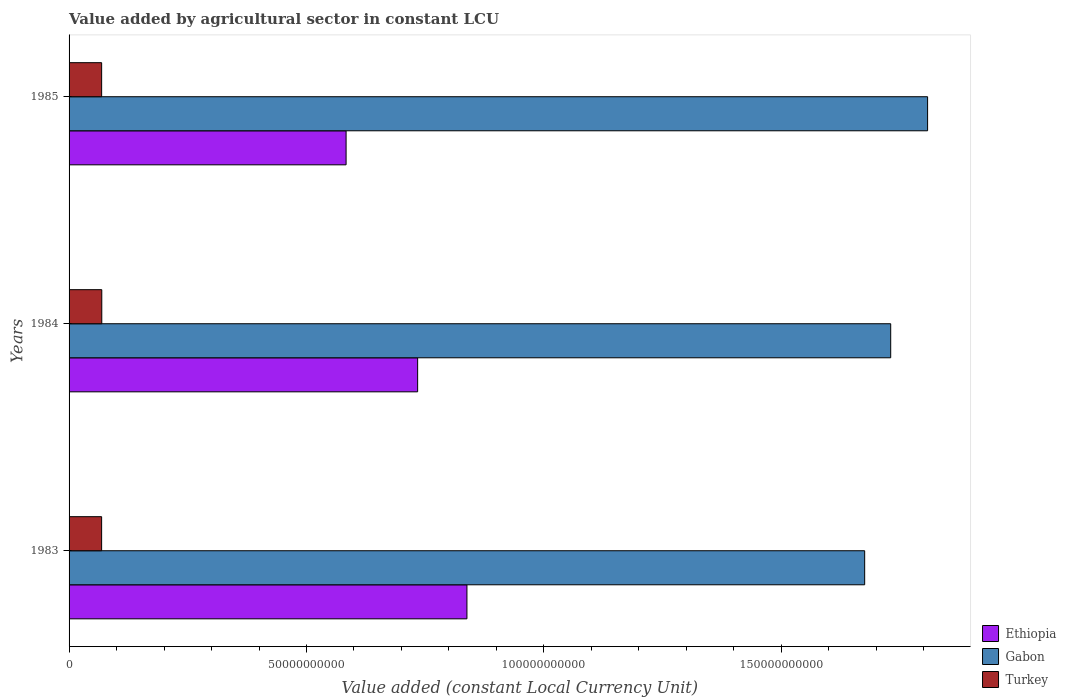How many different coloured bars are there?
Your answer should be very brief. 3. Are the number of bars per tick equal to the number of legend labels?
Keep it short and to the point. Yes. How many bars are there on the 1st tick from the bottom?
Your answer should be very brief. 3. What is the label of the 1st group of bars from the top?
Provide a short and direct response. 1985. What is the value added by agricultural sector in Ethiopia in 1983?
Offer a terse response. 8.38e+1. Across all years, what is the maximum value added by agricultural sector in Gabon?
Provide a succinct answer. 1.81e+11. Across all years, what is the minimum value added by agricultural sector in Turkey?
Provide a short and direct response. 6.86e+09. In which year was the value added by agricultural sector in Turkey maximum?
Your answer should be compact. 1984. In which year was the value added by agricultural sector in Ethiopia minimum?
Give a very brief answer. 1985. What is the total value added by agricultural sector in Turkey in the graph?
Make the answer very short. 2.06e+1. What is the difference between the value added by agricultural sector in Ethiopia in 1983 and that in 1985?
Your answer should be very brief. 2.55e+1. What is the difference between the value added by agricultural sector in Turkey in 1983 and the value added by agricultural sector in Ethiopia in 1984?
Your answer should be very brief. -6.66e+1. What is the average value added by agricultural sector in Ethiopia per year?
Ensure brevity in your answer.  7.18e+1. In the year 1983, what is the difference between the value added by agricultural sector in Turkey and value added by agricultural sector in Gabon?
Provide a short and direct response. -1.61e+11. In how many years, is the value added by agricultural sector in Ethiopia greater than 20000000000 LCU?
Provide a short and direct response. 3. What is the ratio of the value added by agricultural sector in Turkey in 1984 to that in 1985?
Provide a short and direct response. 1. What is the difference between the highest and the second highest value added by agricultural sector in Ethiopia?
Make the answer very short. 1.04e+1. What is the difference between the highest and the lowest value added by agricultural sector in Ethiopia?
Keep it short and to the point. 2.55e+1. What does the 1st bar from the bottom in 1983 represents?
Provide a succinct answer. Ethiopia. Is it the case that in every year, the sum of the value added by agricultural sector in Turkey and value added by agricultural sector in Gabon is greater than the value added by agricultural sector in Ethiopia?
Offer a very short reply. Yes. What is the difference between two consecutive major ticks on the X-axis?
Keep it short and to the point. 5.00e+1. Are the values on the major ticks of X-axis written in scientific E-notation?
Your response must be concise. No. Does the graph contain any zero values?
Provide a succinct answer. No. Does the graph contain grids?
Give a very brief answer. No. How are the legend labels stacked?
Provide a succinct answer. Vertical. What is the title of the graph?
Your answer should be very brief. Value added by agricultural sector in constant LCU. Does "Paraguay" appear as one of the legend labels in the graph?
Offer a very short reply. No. What is the label or title of the X-axis?
Your response must be concise. Value added (constant Local Currency Unit). What is the label or title of the Y-axis?
Provide a succinct answer. Years. What is the Value added (constant Local Currency Unit) in Ethiopia in 1983?
Give a very brief answer. 8.38e+1. What is the Value added (constant Local Currency Unit) of Gabon in 1983?
Your answer should be very brief. 1.68e+11. What is the Value added (constant Local Currency Unit) in Turkey in 1983?
Ensure brevity in your answer.  6.86e+09. What is the Value added (constant Local Currency Unit) of Ethiopia in 1984?
Offer a very short reply. 7.34e+1. What is the Value added (constant Local Currency Unit) in Gabon in 1984?
Your response must be concise. 1.73e+11. What is the Value added (constant Local Currency Unit) of Turkey in 1984?
Ensure brevity in your answer.  6.89e+09. What is the Value added (constant Local Currency Unit) in Ethiopia in 1985?
Your answer should be very brief. 5.83e+1. What is the Value added (constant Local Currency Unit) in Gabon in 1985?
Ensure brevity in your answer.  1.81e+11. What is the Value added (constant Local Currency Unit) of Turkey in 1985?
Keep it short and to the point. 6.86e+09. Across all years, what is the maximum Value added (constant Local Currency Unit) of Ethiopia?
Your answer should be very brief. 8.38e+1. Across all years, what is the maximum Value added (constant Local Currency Unit) in Gabon?
Your answer should be very brief. 1.81e+11. Across all years, what is the maximum Value added (constant Local Currency Unit) in Turkey?
Offer a terse response. 6.89e+09. Across all years, what is the minimum Value added (constant Local Currency Unit) of Ethiopia?
Provide a short and direct response. 5.83e+1. Across all years, what is the minimum Value added (constant Local Currency Unit) of Gabon?
Provide a short and direct response. 1.68e+11. Across all years, what is the minimum Value added (constant Local Currency Unit) of Turkey?
Your response must be concise. 6.86e+09. What is the total Value added (constant Local Currency Unit) in Ethiopia in the graph?
Your response must be concise. 2.16e+11. What is the total Value added (constant Local Currency Unit) in Gabon in the graph?
Provide a short and direct response. 5.21e+11. What is the total Value added (constant Local Currency Unit) in Turkey in the graph?
Your answer should be very brief. 2.06e+1. What is the difference between the Value added (constant Local Currency Unit) of Ethiopia in 1983 and that in 1984?
Offer a very short reply. 1.04e+1. What is the difference between the Value added (constant Local Currency Unit) of Gabon in 1983 and that in 1984?
Ensure brevity in your answer.  -5.48e+09. What is the difference between the Value added (constant Local Currency Unit) of Turkey in 1983 and that in 1984?
Keep it short and to the point. -3.28e+07. What is the difference between the Value added (constant Local Currency Unit) in Ethiopia in 1983 and that in 1985?
Ensure brevity in your answer.  2.55e+1. What is the difference between the Value added (constant Local Currency Unit) in Gabon in 1983 and that in 1985?
Keep it short and to the point. -1.33e+1. What is the difference between the Value added (constant Local Currency Unit) of Turkey in 1983 and that in 1985?
Provide a short and direct response. -1.40e+06. What is the difference between the Value added (constant Local Currency Unit) in Ethiopia in 1984 and that in 1985?
Keep it short and to the point. 1.51e+1. What is the difference between the Value added (constant Local Currency Unit) of Gabon in 1984 and that in 1985?
Your answer should be very brief. -7.77e+09. What is the difference between the Value added (constant Local Currency Unit) of Turkey in 1984 and that in 1985?
Provide a short and direct response. 3.14e+07. What is the difference between the Value added (constant Local Currency Unit) in Ethiopia in 1983 and the Value added (constant Local Currency Unit) in Gabon in 1984?
Make the answer very short. -8.92e+1. What is the difference between the Value added (constant Local Currency Unit) of Ethiopia in 1983 and the Value added (constant Local Currency Unit) of Turkey in 1984?
Provide a short and direct response. 7.69e+1. What is the difference between the Value added (constant Local Currency Unit) of Gabon in 1983 and the Value added (constant Local Currency Unit) of Turkey in 1984?
Offer a very short reply. 1.61e+11. What is the difference between the Value added (constant Local Currency Unit) in Ethiopia in 1983 and the Value added (constant Local Currency Unit) in Gabon in 1985?
Offer a terse response. -9.70e+1. What is the difference between the Value added (constant Local Currency Unit) in Ethiopia in 1983 and the Value added (constant Local Currency Unit) in Turkey in 1985?
Ensure brevity in your answer.  7.69e+1. What is the difference between the Value added (constant Local Currency Unit) of Gabon in 1983 and the Value added (constant Local Currency Unit) of Turkey in 1985?
Offer a very short reply. 1.61e+11. What is the difference between the Value added (constant Local Currency Unit) in Ethiopia in 1984 and the Value added (constant Local Currency Unit) in Gabon in 1985?
Make the answer very short. -1.07e+11. What is the difference between the Value added (constant Local Currency Unit) in Ethiopia in 1984 and the Value added (constant Local Currency Unit) in Turkey in 1985?
Provide a succinct answer. 6.65e+1. What is the difference between the Value added (constant Local Currency Unit) in Gabon in 1984 and the Value added (constant Local Currency Unit) in Turkey in 1985?
Your response must be concise. 1.66e+11. What is the average Value added (constant Local Currency Unit) in Ethiopia per year?
Provide a short and direct response. 7.18e+1. What is the average Value added (constant Local Currency Unit) of Gabon per year?
Keep it short and to the point. 1.74e+11. What is the average Value added (constant Local Currency Unit) of Turkey per year?
Ensure brevity in your answer.  6.87e+09. In the year 1983, what is the difference between the Value added (constant Local Currency Unit) in Ethiopia and Value added (constant Local Currency Unit) in Gabon?
Provide a succinct answer. -8.38e+1. In the year 1983, what is the difference between the Value added (constant Local Currency Unit) in Ethiopia and Value added (constant Local Currency Unit) in Turkey?
Your answer should be compact. 7.69e+1. In the year 1983, what is the difference between the Value added (constant Local Currency Unit) in Gabon and Value added (constant Local Currency Unit) in Turkey?
Give a very brief answer. 1.61e+11. In the year 1984, what is the difference between the Value added (constant Local Currency Unit) in Ethiopia and Value added (constant Local Currency Unit) in Gabon?
Make the answer very short. -9.96e+1. In the year 1984, what is the difference between the Value added (constant Local Currency Unit) of Ethiopia and Value added (constant Local Currency Unit) of Turkey?
Your answer should be very brief. 6.65e+1. In the year 1984, what is the difference between the Value added (constant Local Currency Unit) in Gabon and Value added (constant Local Currency Unit) in Turkey?
Offer a terse response. 1.66e+11. In the year 1985, what is the difference between the Value added (constant Local Currency Unit) of Ethiopia and Value added (constant Local Currency Unit) of Gabon?
Ensure brevity in your answer.  -1.22e+11. In the year 1985, what is the difference between the Value added (constant Local Currency Unit) of Ethiopia and Value added (constant Local Currency Unit) of Turkey?
Ensure brevity in your answer.  5.15e+1. In the year 1985, what is the difference between the Value added (constant Local Currency Unit) of Gabon and Value added (constant Local Currency Unit) of Turkey?
Your answer should be compact. 1.74e+11. What is the ratio of the Value added (constant Local Currency Unit) in Ethiopia in 1983 to that in 1984?
Make the answer very short. 1.14. What is the ratio of the Value added (constant Local Currency Unit) in Gabon in 1983 to that in 1984?
Provide a short and direct response. 0.97. What is the ratio of the Value added (constant Local Currency Unit) in Turkey in 1983 to that in 1984?
Ensure brevity in your answer.  1. What is the ratio of the Value added (constant Local Currency Unit) in Ethiopia in 1983 to that in 1985?
Your answer should be very brief. 1.44. What is the ratio of the Value added (constant Local Currency Unit) in Gabon in 1983 to that in 1985?
Give a very brief answer. 0.93. What is the ratio of the Value added (constant Local Currency Unit) of Ethiopia in 1984 to that in 1985?
Offer a terse response. 1.26. What is the ratio of the Value added (constant Local Currency Unit) of Turkey in 1984 to that in 1985?
Your answer should be compact. 1. What is the difference between the highest and the second highest Value added (constant Local Currency Unit) of Ethiopia?
Provide a short and direct response. 1.04e+1. What is the difference between the highest and the second highest Value added (constant Local Currency Unit) in Gabon?
Your answer should be compact. 7.77e+09. What is the difference between the highest and the second highest Value added (constant Local Currency Unit) of Turkey?
Provide a succinct answer. 3.14e+07. What is the difference between the highest and the lowest Value added (constant Local Currency Unit) in Ethiopia?
Offer a very short reply. 2.55e+1. What is the difference between the highest and the lowest Value added (constant Local Currency Unit) of Gabon?
Your response must be concise. 1.33e+1. What is the difference between the highest and the lowest Value added (constant Local Currency Unit) of Turkey?
Your answer should be very brief. 3.28e+07. 